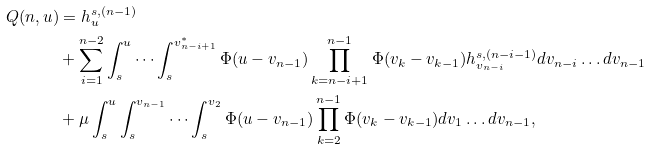<formula> <loc_0><loc_0><loc_500><loc_500>Q ( n , u ) & = h _ { u } ^ { s , ( n - 1 ) } \\ & + \sum _ { i = 1 } ^ { n - 2 } \int _ { s } ^ { u } \cdots \int _ { s } ^ { v _ { n - i + 1 } ^ { * } } \Phi ( u - v _ { n - 1 } ) \prod _ { k = n - i + 1 } ^ { n - 1 } \Phi ( v _ { k } - v _ { k - 1 } ) h _ { v _ { n - i } } ^ { s , ( n - i - 1 ) } d v _ { n - i } \dots d v _ { n - 1 } \\ & + \mu \int _ { s } ^ { u } \int _ { s } ^ { v _ { n - 1 } } \cdots \int _ { s } ^ { v _ { 2 } } \Phi ( u - v _ { n - 1 } ) \prod _ { k = 2 } ^ { n - 1 } \Phi ( v _ { k } - v _ { k - 1 } ) d v _ { 1 } \dots d v _ { n - 1 } ,</formula> 